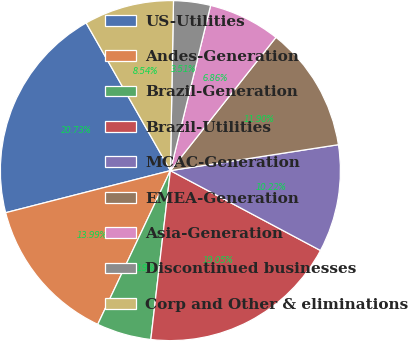<chart> <loc_0><loc_0><loc_500><loc_500><pie_chart><fcel>US-Utilities<fcel>Andes-Generation<fcel>Brazil-Generation<fcel>Brazil-Utilities<fcel>MCAC-Generation<fcel>EMEA-Generation<fcel>Asia-Generation<fcel>Discontinued businesses<fcel>Corp and Other & eliminations<nl><fcel>20.73%<fcel>13.99%<fcel>5.19%<fcel>19.05%<fcel>10.22%<fcel>11.9%<fcel>6.86%<fcel>3.51%<fcel>8.54%<nl></chart> 